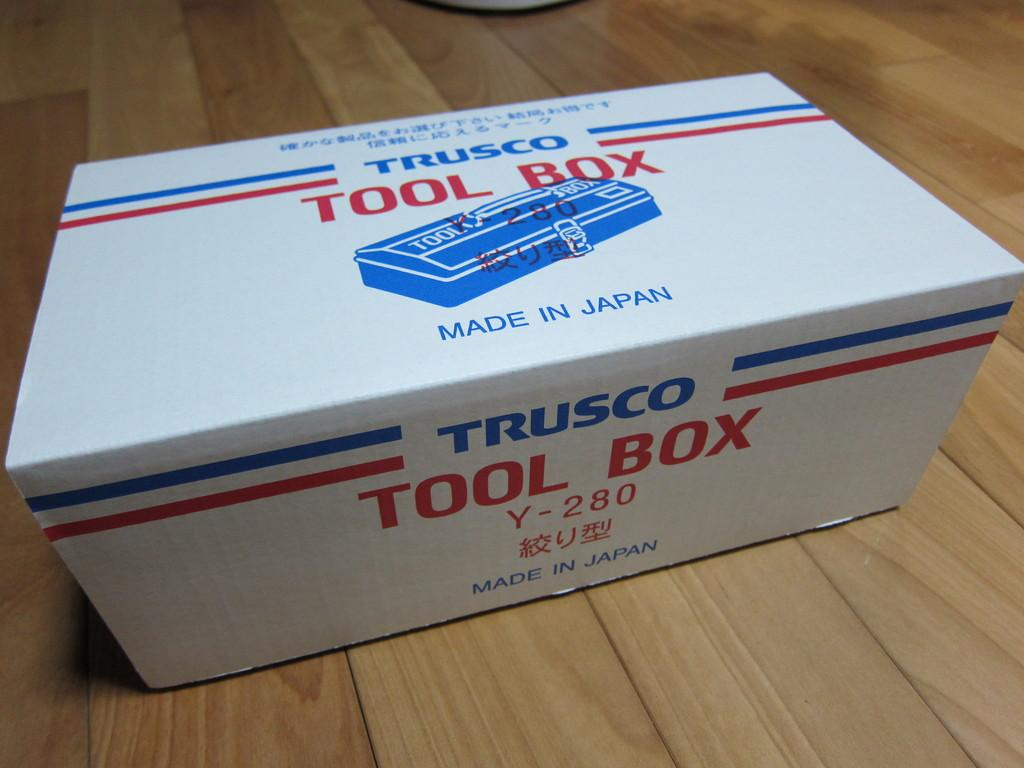<image>
Create a compact narrative representing the image presented. A white Trusco Tool Box on a wood floor. 